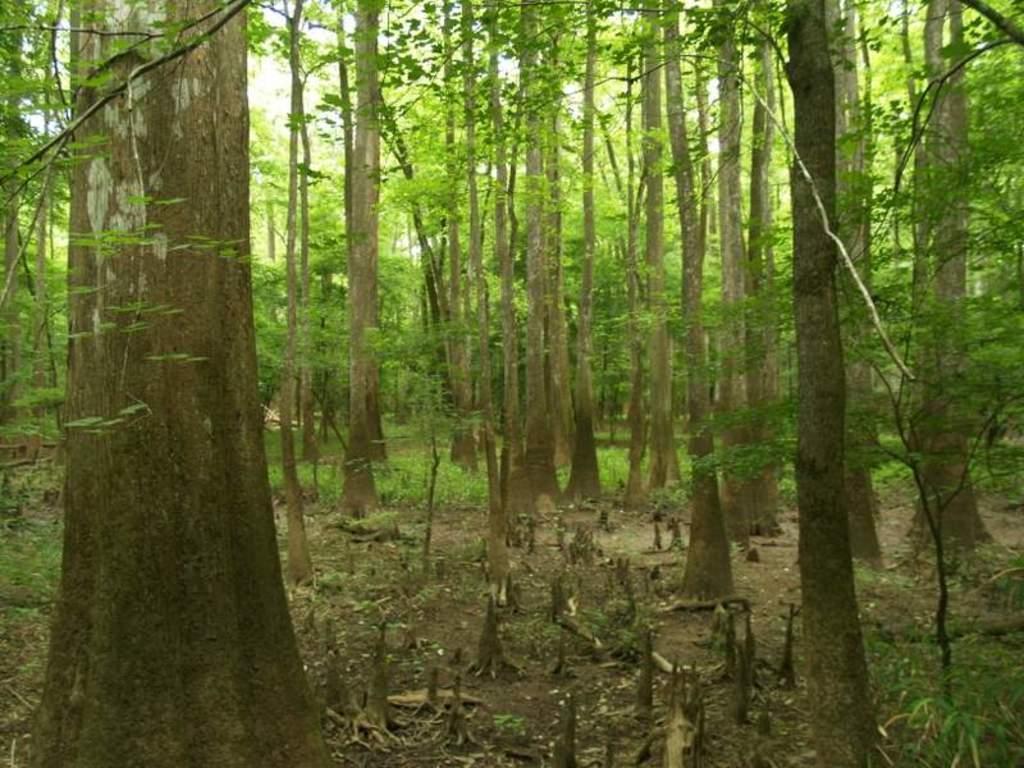Could you give a brief overview of what you see in this image? In the image there are many trees. On the ground there are dry leaves and also wooden pieces. 